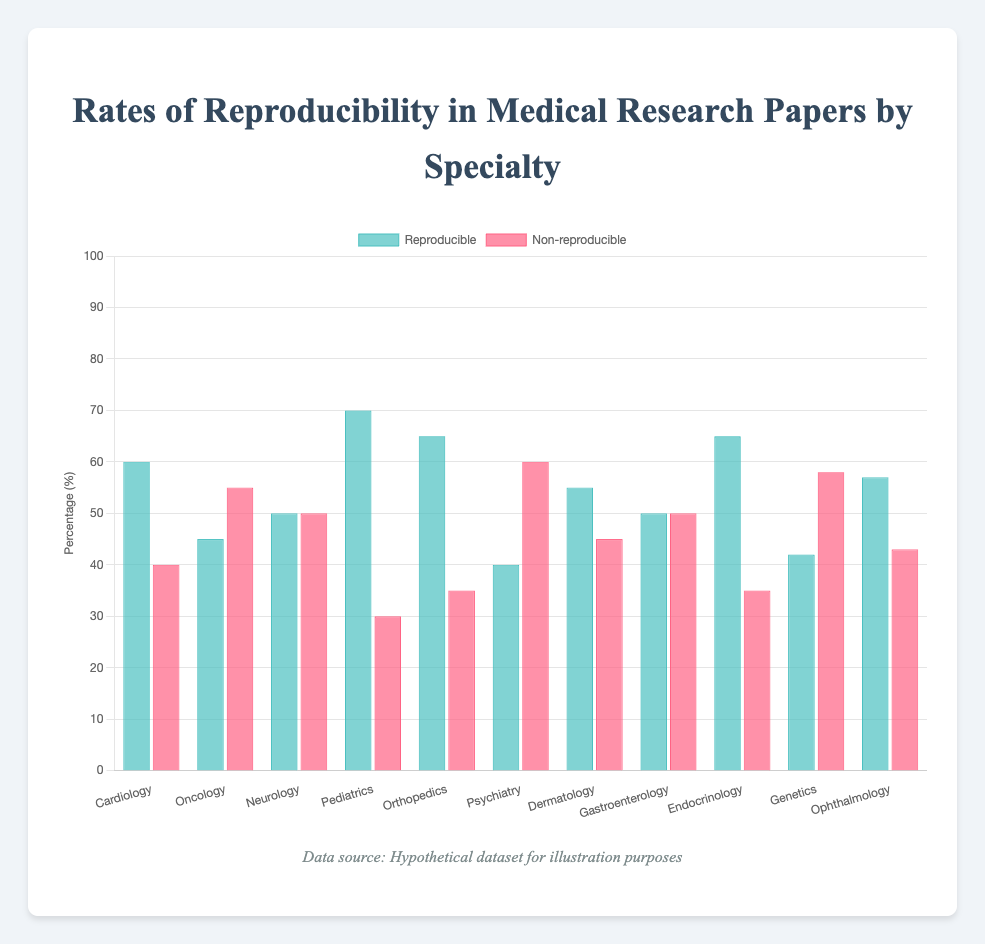Which specialty has the highest reproducibility rate? Look at the bar heights in the 'Reproducible' category. The specialty with the tallest bar has the highest reproducibility rate. Pediatrics has the tallest bar at 70%.
Answer: Pediatrics Which specialty has the lowest reproducibility rate? Look at the bar heights in the 'Reproducible' category. The specialty with the shortest bar has the lowest reproducibility rate. Psychiatry has the shortest bar at 40%.
Answer: Psychiatry What is the average reproducibility rate across all specialties? Add up all the reproducible rates and divide by the number of specialties: (60 + 45 + 50 + 70 + 65 + 40 + 55 + 50 + 65 + 42 + 57)/11 = 55.
Answer: 55 Which specialties have an equal rate of reproducible and non-reproducible results? Look for bars that have the same height in both 'Reproducible' and 'Non-reproducible' categories. Neurology and Gastroenterology have equal bars at 50%.
Answer: Neurology and Gastroenterology How many specialties have a reproducibility rate higher than 60%? Identify the bars in the 'Reproducible' category that are higher than 60%. Cardiology, Pediatrics, Orthopedics, and Endocrinology have reproducibility rates higher than 60%.
Answer: 4 What is the difference in reproducibility rates between Oncology and Pediatrics? Subtract the reproducibility rate of Oncology from that of Pediatrics: 70 - 45 = 25.
Answer: 25 Which specialty has a greater rate of reproducibility, Cardiology or Orthopedics? Compare the bar heights in the 'Reproducible' category between Cardiology and Orthopedics. Orthopedics has a higher rate (65%) compared to Cardiology (60%).
Answer: Orthopedics What is the combined reproducibility rate of Dermatology and Endocrinology? Add the reproducibility rates of Dermatology and Endocrinology: 55 + 65 = 120.
Answer: 120 What is the sum of all non-reproducible rates in specialties starting with the letter "O"? Add the non-reproducible rates of Oncology, Orthopedics, and Ophthalmology: 55 + 35 + 43 = 133.
Answer: 133 How many specialties have a reproducibility rate of 50% or less? Count the bars in the 'Reproducible' category that are 50% or less. Oncology, Neurology, Psychiatry, Gastroenterology, and Genetics have reproducibility rates of 50% or less.
Answer: 5 